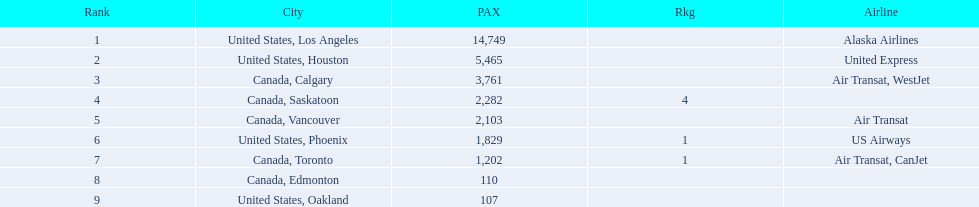Los angeles and what other city had about 19,000 passenger combined Canada, Calgary. 